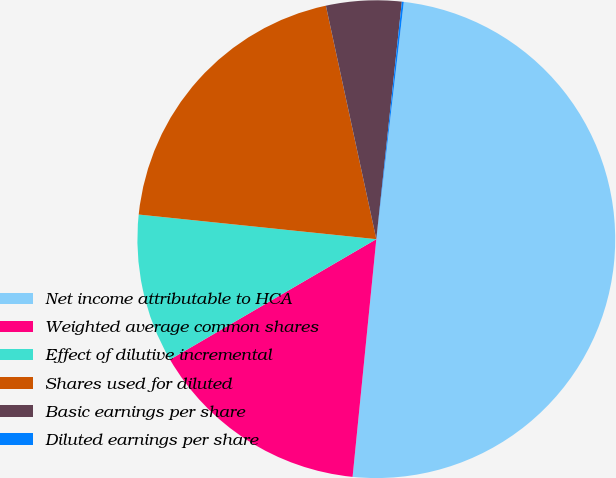Convert chart to OTSL. <chart><loc_0><loc_0><loc_500><loc_500><pie_chart><fcel>Net income attributable to HCA<fcel>Weighted average common shares<fcel>Effect of dilutive incremental<fcel>Shares used for diluted<fcel>Basic earnings per share<fcel>Diluted earnings per share<nl><fcel>49.75%<fcel>15.01%<fcel>10.05%<fcel>19.97%<fcel>5.09%<fcel>0.13%<nl></chart> 